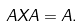<formula> <loc_0><loc_0><loc_500><loc_500>A X A = A .</formula> 